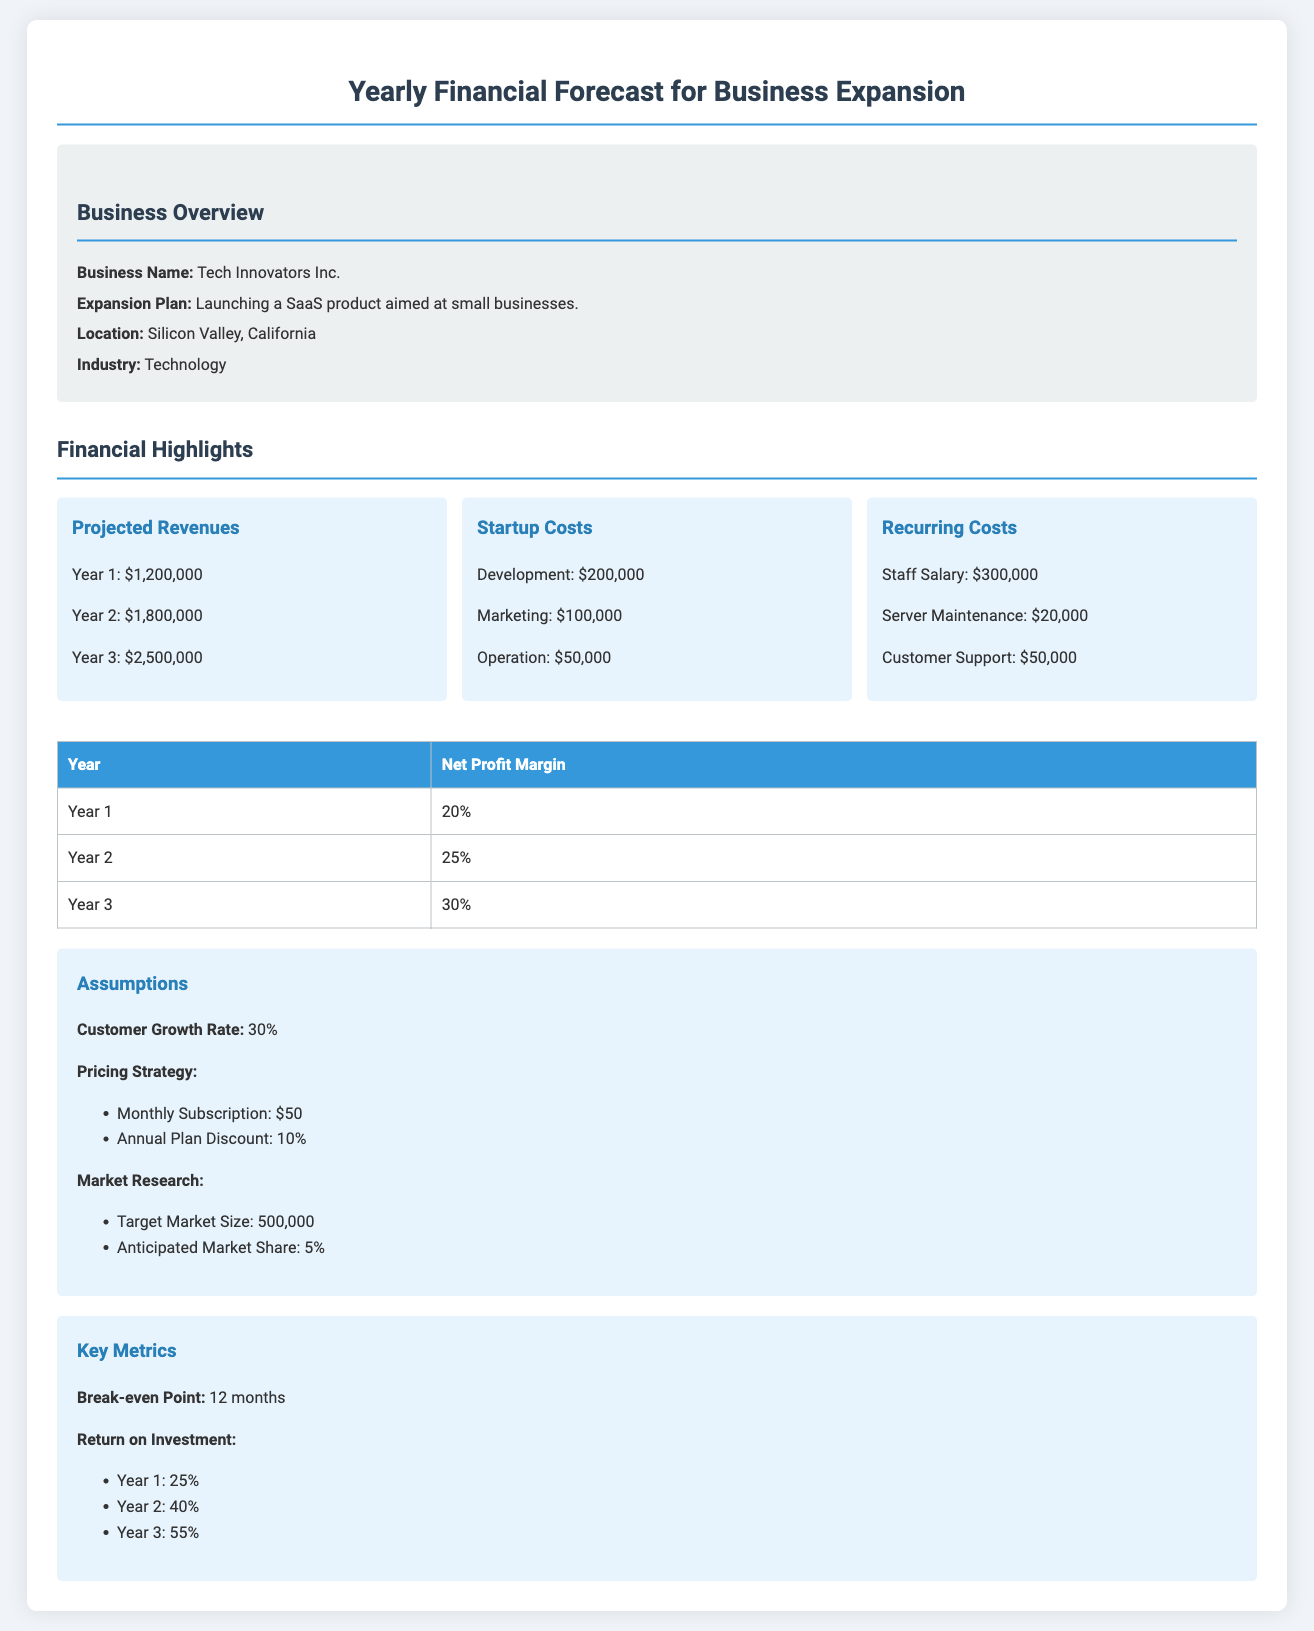What is the business name? The business name is explicitly mentioned in the document under the Business Overview section.
Answer: Tech Innovators Inc What is the projected revenue for Year 2? The projected revenues for each year are listed in the Financial Highlights section of the document.
Answer: $1,800,000 What are the startup costs for development? The startup costs are detailed in the Financial Highlights section of the document.
Answer: $200,000 What is the customer growth rate assumption? The assumptions made for customer growth are outlined in the Assumptions section.
Answer: 30% What is the net profit margin for Year 3? Net profit margins for different years are provided in a table in the document.
Answer: 30% What is the break-even point? The break-even point is mentioned in the Key Metrics section.
Answer: 12 months What is the anticipated market share? This information is provided under the Market Research subsection of the Assumptions section.
Answer: 5% What is the return on investment for Year 1? The return on investment for each year is listed in the Key Metrics section of the document.
Answer: 25% What is the operation cost in startup costs? The operational costs are specifically indicated in the Financial Highlights section.
Answer: $50,000 